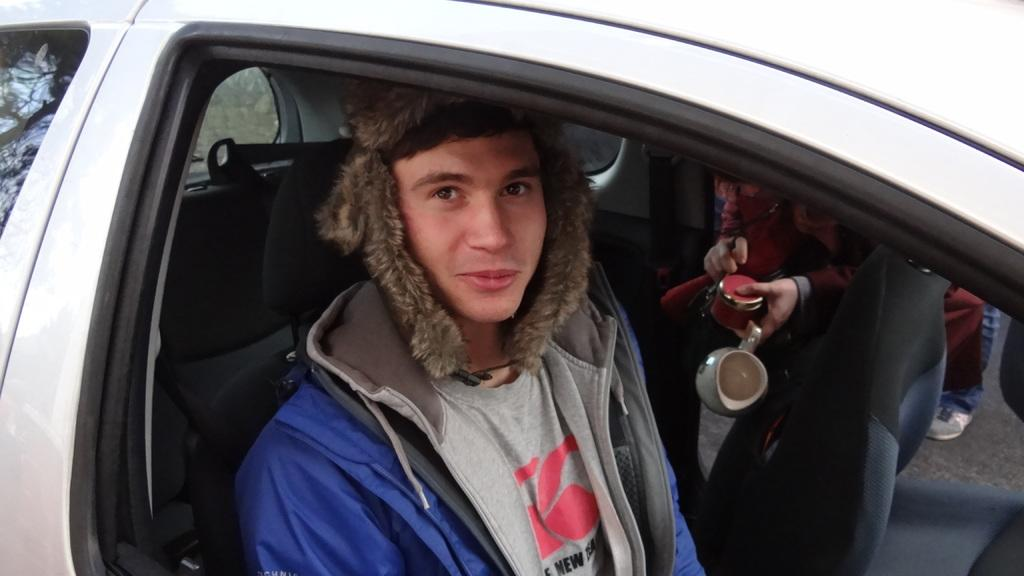Who is present in the image? There is a man in the image. Where is the man located? The man is inside a vehicle. What is the man holding in his hands? The man is holding a cup and a bottle. What type of spot can be seen on the man's shirt in the image? There is no spot visible on the man's shirt in the image. Can you tell me how many boats are in the harbor in the image? There is no harbor or boats present in the image. 